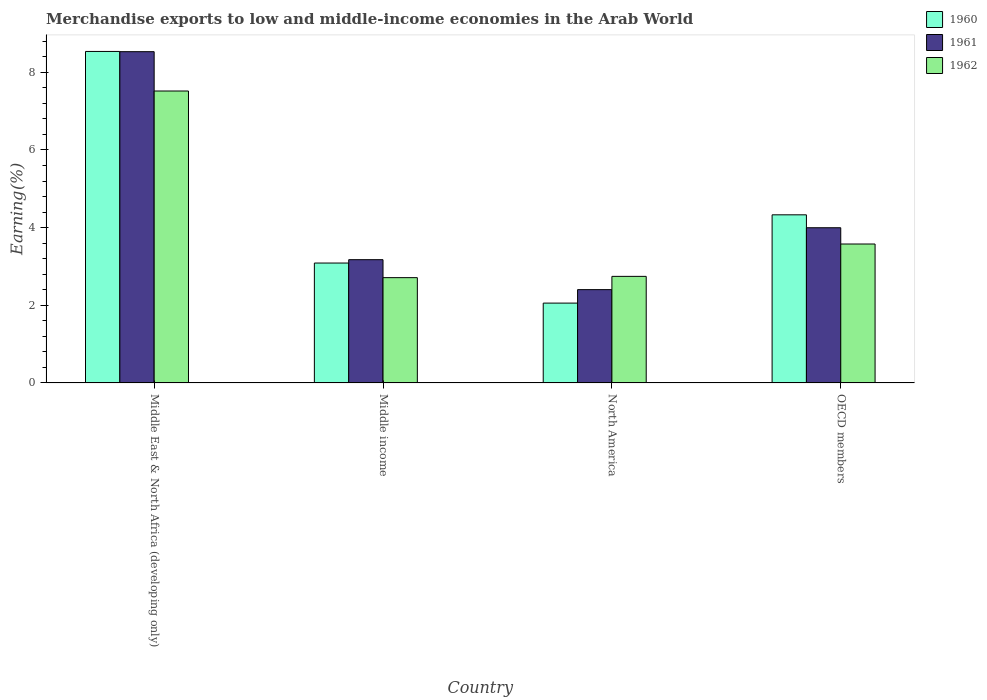Are the number of bars per tick equal to the number of legend labels?
Offer a very short reply. Yes. Are the number of bars on each tick of the X-axis equal?
Your answer should be compact. Yes. How many bars are there on the 1st tick from the left?
Your answer should be compact. 3. What is the label of the 2nd group of bars from the left?
Your answer should be compact. Middle income. In how many cases, is the number of bars for a given country not equal to the number of legend labels?
Ensure brevity in your answer.  0. What is the percentage of amount earned from merchandise exports in 1962 in Middle East & North Africa (developing only)?
Provide a short and direct response. 7.52. Across all countries, what is the maximum percentage of amount earned from merchandise exports in 1962?
Ensure brevity in your answer.  7.52. Across all countries, what is the minimum percentage of amount earned from merchandise exports in 1960?
Make the answer very short. 2.06. In which country was the percentage of amount earned from merchandise exports in 1962 maximum?
Provide a succinct answer. Middle East & North Africa (developing only). In which country was the percentage of amount earned from merchandise exports in 1960 minimum?
Provide a short and direct response. North America. What is the total percentage of amount earned from merchandise exports in 1962 in the graph?
Make the answer very short. 16.55. What is the difference between the percentage of amount earned from merchandise exports in 1962 in Middle East & North Africa (developing only) and that in OECD members?
Keep it short and to the point. 3.94. What is the difference between the percentage of amount earned from merchandise exports in 1961 in Middle income and the percentage of amount earned from merchandise exports in 1962 in North America?
Provide a succinct answer. 0.43. What is the average percentage of amount earned from merchandise exports in 1961 per country?
Your answer should be very brief. 4.53. What is the difference between the percentage of amount earned from merchandise exports of/in 1961 and percentage of amount earned from merchandise exports of/in 1962 in North America?
Offer a terse response. -0.34. What is the ratio of the percentage of amount earned from merchandise exports in 1962 in Middle income to that in OECD members?
Make the answer very short. 0.76. Is the percentage of amount earned from merchandise exports in 1961 in Middle income less than that in OECD members?
Make the answer very short. Yes. Is the difference between the percentage of amount earned from merchandise exports in 1961 in Middle East & North Africa (developing only) and OECD members greater than the difference between the percentage of amount earned from merchandise exports in 1962 in Middle East & North Africa (developing only) and OECD members?
Your response must be concise. Yes. What is the difference between the highest and the second highest percentage of amount earned from merchandise exports in 1960?
Offer a terse response. 5.45. What is the difference between the highest and the lowest percentage of amount earned from merchandise exports in 1962?
Keep it short and to the point. 4.81. Is the sum of the percentage of amount earned from merchandise exports in 1961 in Middle East & North Africa (developing only) and OECD members greater than the maximum percentage of amount earned from merchandise exports in 1962 across all countries?
Your answer should be very brief. Yes. Is it the case that in every country, the sum of the percentage of amount earned from merchandise exports in 1962 and percentage of amount earned from merchandise exports in 1960 is greater than the percentage of amount earned from merchandise exports in 1961?
Your response must be concise. Yes. How many bars are there?
Your response must be concise. 12. Are all the bars in the graph horizontal?
Ensure brevity in your answer.  No. What is the difference between two consecutive major ticks on the Y-axis?
Offer a very short reply. 2. Are the values on the major ticks of Y-axis written in scientific E-notation?
Keep it short and to the point. No. Where does the legend appear in the graph?
Offer a terse response. Top right. What is the title of the graph?
Your answer should be very brief. Merchandise exports to low and middle-income economies in the Arab World. What is the label or title of the Y-axis?
Make the answer very short. Earning(%). What is the Earning(%) in 1960 in Middle East & North Africa (developing only)?
Your answer should be compact. 8.54. What is the Earning(%) of 1961 in Middle East & North Africa (developing only)?
Ensure brevity in your answer.  8.53. What is the Earning(%) in 1962 in Middle East & North Africa (developing only)?
Keep it short and to the point. 7.52. What is the Earning(%) of 1960 in Middle income?
Offer a terse response. 3.09. What is the Earning(%) in 1961 in Middle income?
Ensure brevity in your answer.  3.17. What is the Earning(%) of 1962 in Middle income?
Give a very brief answer. 2.71. What is the Earning(%) of 1960 in North America?
Ensure brevity in your answer.  2.06. What is the Earning(%) of 1961 in North America?
Ensure brevity in your answer.  2.4. What is the Earning(%) in 1962 in North America?
Your answer should be compact. 2.74. What is the Earning(%) of 1960 in OECD members?
Your answer should be very brief. 4.33. What is the Earning(%) of 1961 in OECD members?
Your answer should be very brief. 4. What is the Earning(%) of 1962 in OECD members?
Offer a very short reply. 3.58. Across all countries, what is the maximum Earning(%) of 1960?
Offer a terse response. 8.54. Across all countries, what is the maximum Earning(%) of 1961?
Keep it short and to the point. 8.53. Across all countries, what is the maximum Earning(%) of 1962?
Give a very brief answer. 7.52. Across all countries, what is the minimum Earning(%) in 1960?
Keep it short and to the point. 2.06. Across all countries, what is the minimum Earning(%) in 1961?
Give a very brief answer. 2.4. Across all countries, what is the minimum Earning(%) of 1962?
Your answer should be compact. 2.71. What is the total Earning(%) of 1960 in the graph?
Make the answer very short. 18.01. What is the total Earning(%) in 1961 in the graph?
Ensure brevity in your answer.  18.11. What is the total Earning(%) in 1962 in the graph?
Provide a succinct answer. 16.55. What is the difference between the Earning(%) of 1960 in Middle East & North Africa (developing only) and that in Middle income?
Offer a very short reply. 5.45. What is the difference between the Earning(%) in 1961 in Middle East & North Africa (developing only) and that in Middle income?
Your answer should be very brief. 5.36. What is the difference between the Earning(%) of 1962 in Middle East & North Africa (developing only) and that in Middle income?
Provide a short and direct response. 4.81. What is the difference between the Earning(%) in 1960 in Middle East & North Africa (developing only) and that in North America?
Provide a succinct answer. 6.48. What is the difference between the Earning(%) in 1961 in Middle East & North Africa (developing only) and that in North America?
Your response must be concise. 6.13. What is the difference between the Earning(%) of 1962 in Middle East & North Africa (developing only) and that in North America?
Offer a very short reply. 4.77. What is the difference between the Earning(%) of 1960 in Middle East & North Africa (developing only) and that in OECD members?
Ensure brevity in your answer.  4.21. What is the difference between the Earning(%) of 1961 in Middle East & North Africa (developing only) and that in OECD members?
Your answer should be very brief. 4.53. What is the difference between the Earning(%) of 1962 in Middle East & North Africa (developing only) and that in OECD members?
Your answer should be compact. 3.94. What is the difference between the Earning(%) in 1960 in Middle income and that in North America?
Your answer should be compact. 1.03. What is the difference between the Earning(%) in 1961 in Middle income and that in North America?
Give a very brief answer. 0.77. What is the difference between the Earning(%) of 1962 in Middle income and that in North America?
Offer a terse response. -0.03. What is the difference between the Earning(%) of 1960 in Middle income and that in OECD members?
Keep it short and to the point. -1.24. What is the difference between the Earning(%) in 1961 in Middle income and that in OECD members?
Make the answer very short. -0.82. What is the difference between the Earning(%) of 1962 in Middle income and that in OECD members?
Offer a terse response. -0.87. What is the difference between the Earning(%) in 1960 in North America and that in OECD members?
Give a very brief answer. -2.27. What is the difference between the Earning(%) of 1961 in North America and that in OECD members?
Your response must be concise. -1.59. What is the difference between the Earning(%) of 1962 in North America and that in OECD members?
Make the answer very short. -0.83. What is the difference between the Earning(%) of 1960 in Middle East & North Africa (developing only) and the Earning(%) of 1961 in Middle income?
Keep it short and to the point. 5.36. What is the difference between the Earning(%) in 1960 in Middle East & North Africa (developing only) and the Earning(%) in 1962 in Middle income?
Provide a succinct answer. 5.83. What is the difference between the Earning(%) in 1961 in Middle East & North Africa (developing only) and the Earning(%) in 1962 in Middle income?
Provide a succinct answer. 5.82. What is the difference between the Earning(%) of 1960 in Middle East & North Africa (developing only) and the Earning(%) of 1961 in North America?
Keep it short and to the point. 6.13. What is the difference between the Earning(%) in 1960 in Middle East & North Africa (developing only) and the Earning(%) in 1962 in North America?
Your answer should be very brief. 5.79. What is the difference between the Earning(%) in 1961 in Middle East & North Africa (developing only) and the Earning(%) in 1962 in North America?
Make the answer very short. 5.79. What is the difference between the Earning(%) of 1960 in Middle East & North Africa (developing only) and the Earning(%) of 1961 in OECD members?
Your response must be concise. 4.54. What is the difference between the Earning(%) in 1960 in Middle East & North Africa (developing only) and the Earning(%) in 1962 in OECD members?
Your response must be concise. 4.96. What is the difference between the Earning(%) in 1961 in Middle East & North Africa (developing only) and the Earning(%) in 1962 in OECD members?
Make the answer very short. 4.95. What is the difference between the Earning(%) in 1960 in Middle income and the Earning(%) in 1961 in North America?
Your answer should be compact. 0.68. What is the difference between the Earning(%) in 1960 in Middle income and the Earning(%) in 1962 in North America?
Your answer should be very brief. 0.34. What is the difference between the Earning(%) of 1961 in Middle income and the Earning(%) of 1962 in North America?
Your response must be concise. 0.43. What is the difference between the Earning(%) of 1960 in Middle income and the Earning(%) of 1961 in OECD members?
Make the answer very short. -0.91. What is the difference between the Earning(%) in 1960 in Middle income and the Earning(%) in 1962 in OECD members?
Your answer should be compact. -0.49. What is the difference between the Earning(%) of 1961 in Middle income and the Earning(%) of 1962 in OECD members?
Ensure brevity in your answer.  -0.4. What is the difference between the Earning(%) of 1960 in North America and the Earning(%) of 1961 in OECD members?
Ensure brevity in your answer.  -1.94. What is the difference between the Earning(%) of 1960 in North America and the Earning(%) of 1962 in OECD members?
Your answer should be very brief. -1.52. What is the difference between the Earning(%) of 1961 in North America and the Earning(%) of 1962 in OECD members?
Keep it short and to the point. -1.17. What is the average Earning(%) in 1960 per country?
Ensure brevity in your answer.  4.5. What is the average Earning(%) in 1961 per country?
Your response must be concise. 4.53. What is the average Earning(%) of 1962 per country?
Your response must be concise. 4.14. What is the difference between the Earning(%) in 1960 and Earning(%) in 1961 in Middle East & North Africa (developing only)?
Make the answer very short. 0.01. What is the difference between the Earning(%) in 1960 and Earning(%) in 1962 in Middle East & North Africa (developing only)?
Keep it short and to the point. 1.02. What is the difference between the Earning(%) of 1961 and Earning(%) of 1962 in Middle East & North Africa (developing only)?
Make the answer very short. 1.01. What is the difference between the Earning(%) of 1960 and Earning(%) of 1961 in Middle income?
Your answer should be very brief. -0.09. What is the difference between the Earning(%) in 1960 and Earning(%) in 1962 in Middle income?
Offer a terse response. 0.38. What is the difference between the Earning(%) of 1961 and Earning(%) of 1962 in Middle income?
Ensure brevity in your answer.  0.46. What is the difference between the Earning(%) of 1960 and Earning(%) of 1961 in North America?
Give a very brief answer. -0.35. What is the difference between the Earning(%) of 1960 and Earning(%) of 1962 in North America?
Your answer should be very brief. -0.69. What is the difference between the Earning(%) of 1961 and Earning(%) of 1962 in North America?
Provide a short and direct response. -0.34. What is the difference between the Earning(%) in 1960 and Earning(%) in 1961 in OECD members?
Keep it short and to the point. 0.33. What is the difference between the Earning(%) in 1960 and Earning(%) in 1962 in OECD members?
Offer a very short reply. 0.75. What is the difference between the Earning(%) of 1961 and Earning(%) of 1962 in OECD members?
Keep it short and to the point. 0.42. What is the ratio of the Earning(%) of 1960 in Middle East & North Africa (developing only) to that in Middle income?
Offer a very short reply. 2.76. What is the ratio of the Earning(%) of 1961 in Middle East & North Africa (developing only) to that in Middle income?
Make the answer very short. 2.69. What is the ratio of the Earning(%) of 1962 in Middle East & North Africa (developing only) to that in Middle income?
Provide a succinct answer. 2.77. What is the ratio of the Earning(%) of 1960 in Middle East & North Africa (developing only) to that in North America?
Your answer should be compact. 4.15. What is the ratio of the Earning(%) in 1961 in Middle East & North Africa (developing only) to that in North America?
Ensure brevity in your answer.  3.55. What is the ratio of the Earning(%) in 1962 in Middle East & North Africa (developing only) to that in North America?
Give a very brief answer. 2.74. What is the ratio of the Earning(%) of 1960 in Middle East & North Africa (developing only) to that in OECD members?
Your response must be concise. 1.97. What is the ratio of the Earning(%) of 1961 in Middle East & North Africa (developing only) to that in OECD members?
Offer a terse response. 2.13. What is the ratio of the Earning(%) of 1962 in Middle East & North Africa (developing only) to that in OECD members?
Offer a terse response. 2.1. What is the ratio of the Earning(%) in 1960 in Middle income to that in North America?
Offer a terse response. 1.5. What is the ratio of the Earning(%) in 1961 in Middle income to that in North America?
Your answer should be very brief. 1.32. What is the ratio of the Earning(%) of 1962 in Middle income to that in North America?
Keep it short and to the point. 0.99. What is the ratio of the Earning(%) of 1960 in Middle income to that in OECD members?
Ensure brevity in your answer.  0.71. What is the ratio of the Earning(%) in 1961 in Middle income to that in OECD members?
Your response must be concise. 0.79. What is the ratio of the Earning(%) in 1962 in Middle income to that in OECD members?
Offer a terse response. 0.76. What is the ratio of the Earning(%) of 1960 in North America to that in OECD members?
Ensure brevity in your answer.  0.47. What is the ratio of the Earning(%) of 1961 in North America to that in OECD members?
Make the answer very short. 0.6. What is the ratio of the Earning(%) in 1962 in North America to that in OECD members?
Provide a short and direct response. 0.77. What is the difference between the highest and the second highest Earning(%) in 1960?
Offer a terse response. 4.21. What is the difference between the highest and the second highest Earning(%) in 1961?
Your answer should be very brief. 4.53. What is the difference between the highest and the second highest Earning(%) in 1962?
Offer a very short reply. 3.94. What is the difference between the highest and the lowest Earning(%) of 1960?
Your response must be concise. 6.48. What is the difference between the highest and the lowest Earning(%) of 1961?
Offer a terse response. 6.13. What is the difference between the highest and the lowest Earning(%) of 1962?
Your answer should be very brief. 4.81. 